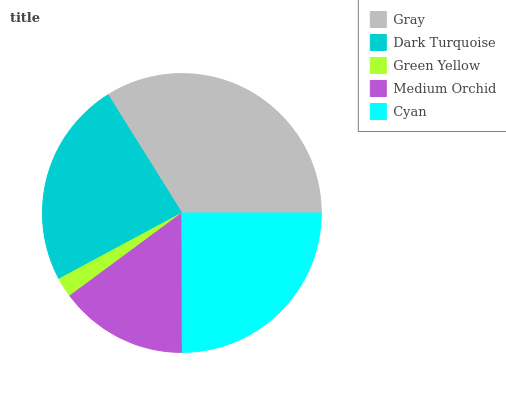Is Green Yellow the minimum?
Answer yes or no. Yes. Is Gray the maximum?
Answer yes or no. Yes. Is Dark Turquoise the minimum?
Answer yes or no. No. Is Dark Turquoise the maximum?
Answer yes or no. No. Is Gray greater than Dark Turquoise?
Answer yes or no. Yes. Is Dark Turquoise less than Gray?
Answer yes or no. Yes. Is Dark Turquoise greater than Gray?
Answer yes or no. No. Is Gray less than Dark Turquoise?
Answer yes or no. No. Is Dark Turquoise the high median?
Answer yes or no. Yes. Is Dark Turquoise the low median?
Answer yes or no. Yes. Is Green Yellow the high median?
Answer yes or no. No. Is Gray the low median?
Answer yes or no. No. 